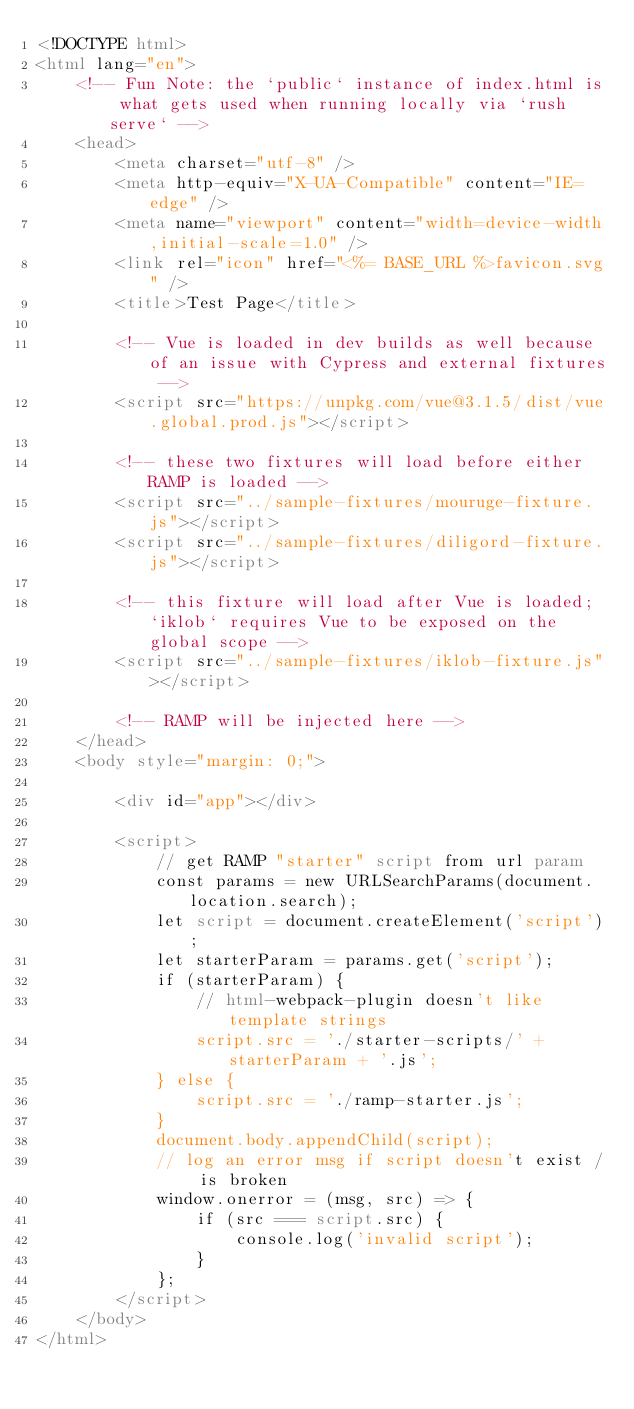<code> <loc_0><loc_0><loc_500><loc_500><_HTML_><!DOCTYPE html>
<html lang="en">
    <!-- Fun Note: the `public` instance of index.html is what gets used when running locally via `rush serve` -->
    <head>
        <meta charset="utf-8" />
        <meta http-equiv="X-UA-Compatible" content="IE=edge" />
        <meta name="viewport" content="width=device-width,initial-scale=1.0" />
        <link rel="icon" href="<%= BASE_URL %>favicon.svg" />
        <title>Test Page</title>

        <!-- Vue is loaded in dev builds as well because of an issue with Cypress and external fixtures -->
        <script src="https://unpkg.com/vue@3.1.5/dist/vue.global.prod.js"></script>

        <!-- these two fixtures will load before either RAMP is loaded -->
        <script src="../sample-fixtures/mouruge-fixture.js"></script>
        <script src="../sample-fixtures/diligord-fixture.js"></script>

        <!-- this fixture will load after Vue is loaded; `iklob` requires Vue to be exposed on the global scope -->
        <script src="../sample-fixtures/iklob-fixture.js"></script>

        <!-- RAMP will be injected here -->
    </head>
    <body style="margin: 0;">

        <div id="app"></div>

        <script>
            // get RAMP "starter" script from url param
            const params = new URLSearchParams(document.location.search);
            let script = document.createElement('script');
            let starterParam = params.get('script');
            if (starterParam) {
                // html-webpack-plugin doesn't like template strings
                script.src = './starter-scripts/' + starterParam + '.js';
            } else {
                script.src = './ramp-starter.js';
            }
            document.body.appendChild(script);
            // log an error msg if script doesn't exist / is broken
            window.onerror = (msg, src) => {
                if (src === script.src) {
                    console.log('invalid script');
                }
            };
        </script>
    </body>
</html>
</code> 